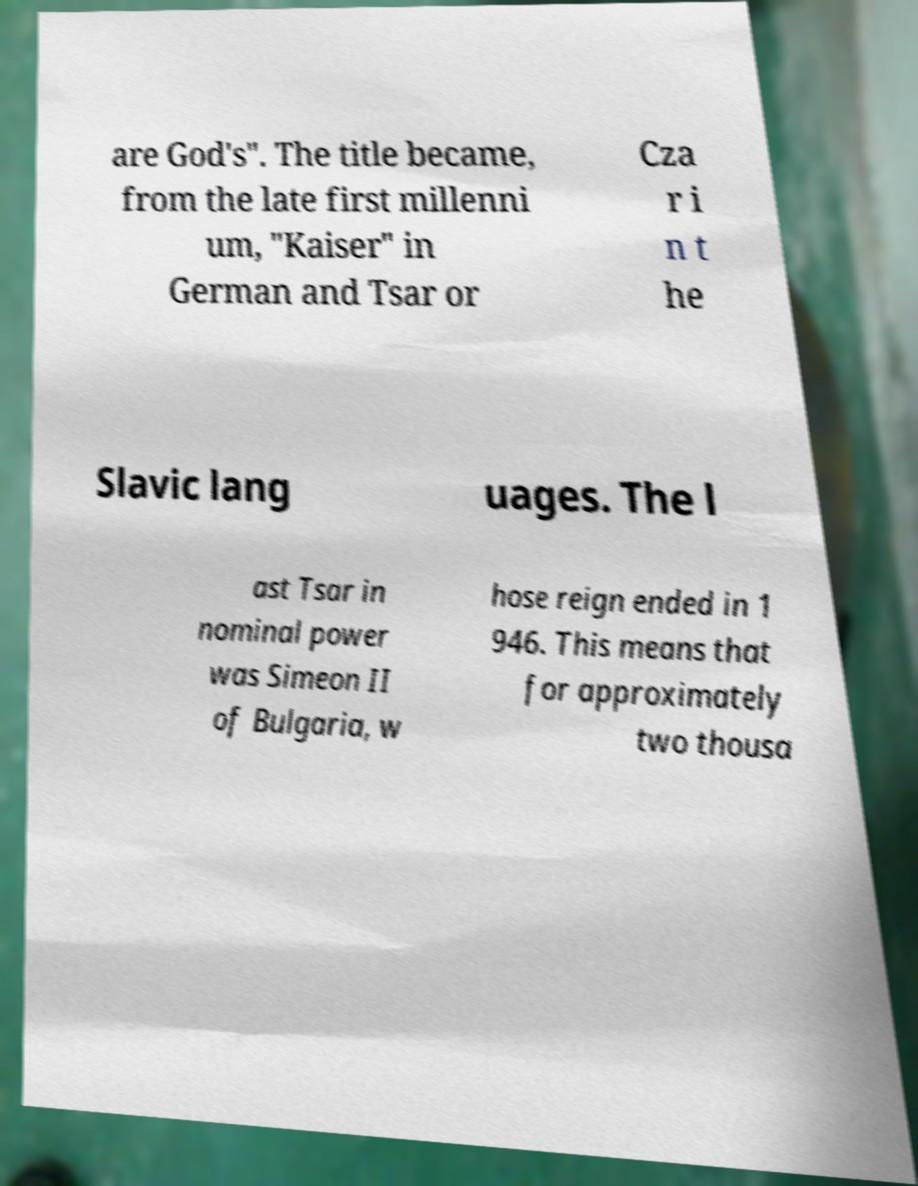Can you accurately transcribe the text from the provided image for me? are God's". The title became, from the late first millenni um, "Kaiser" in German and Tsar or Cza r i n t he Slavic lang uages. The l ast Tsar in nominal power was Simeon II of Bulgaria, w hose reign ended in 1 946. This means that for approximately two thousa 